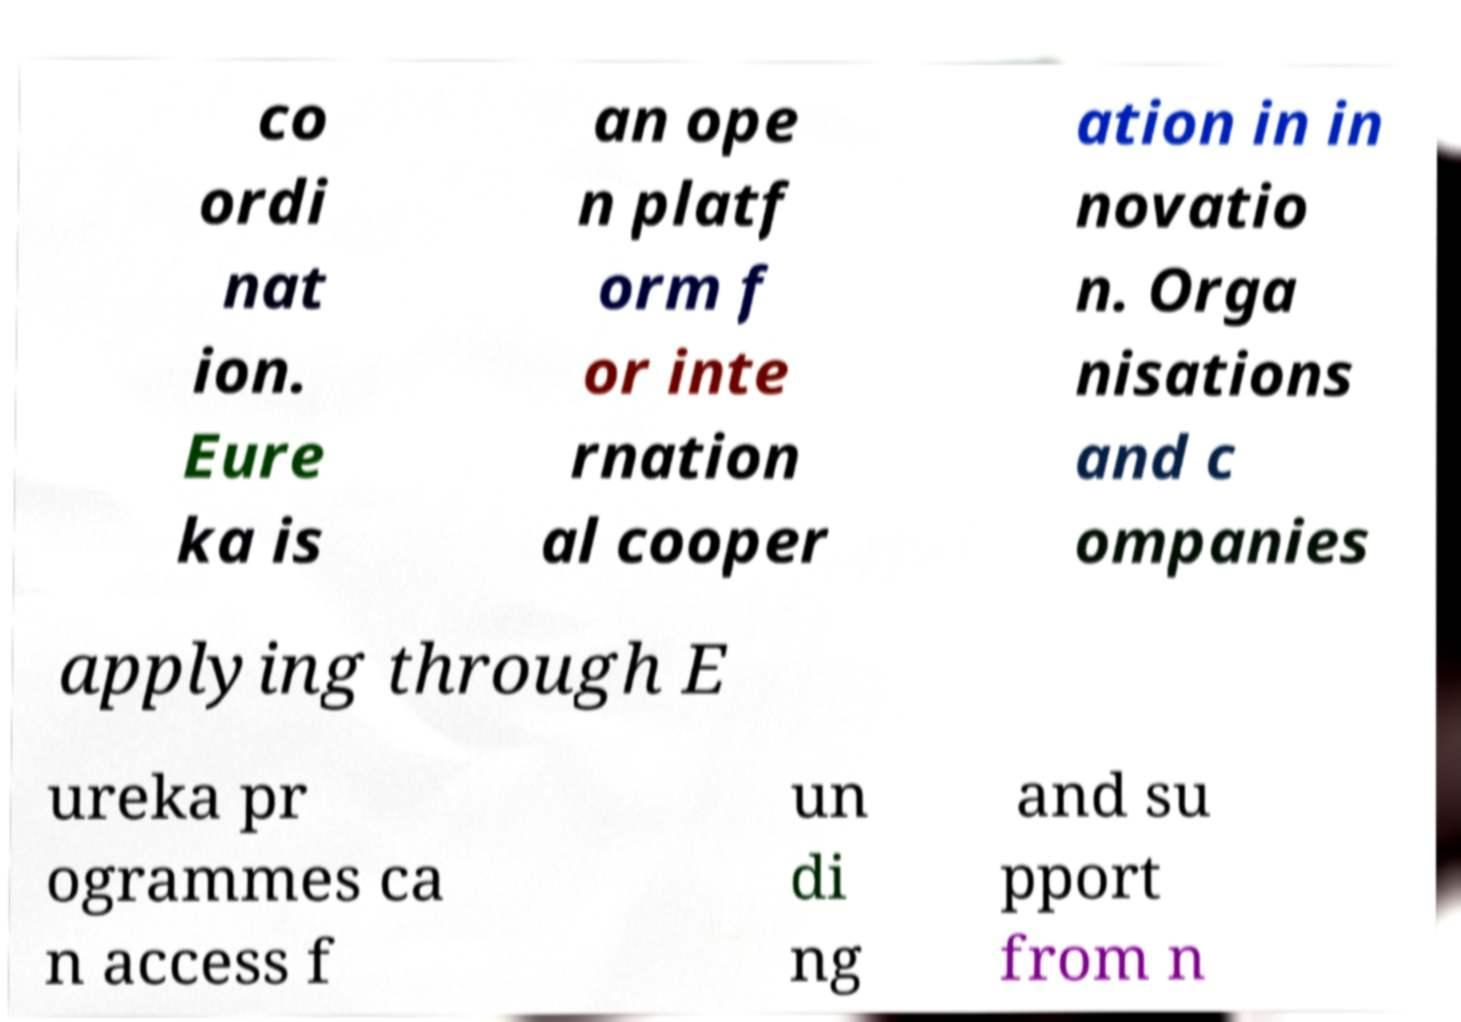Please read and relay the text visible in this image. What does it say? co ordi nat ion. Eure ka is an ope n platf orm f or inte rnation al cooper ation in in novatio n. Orga nisations and c ompanies applying through E ureka pr ogrammes ca n access f un di ng and su pport from n 